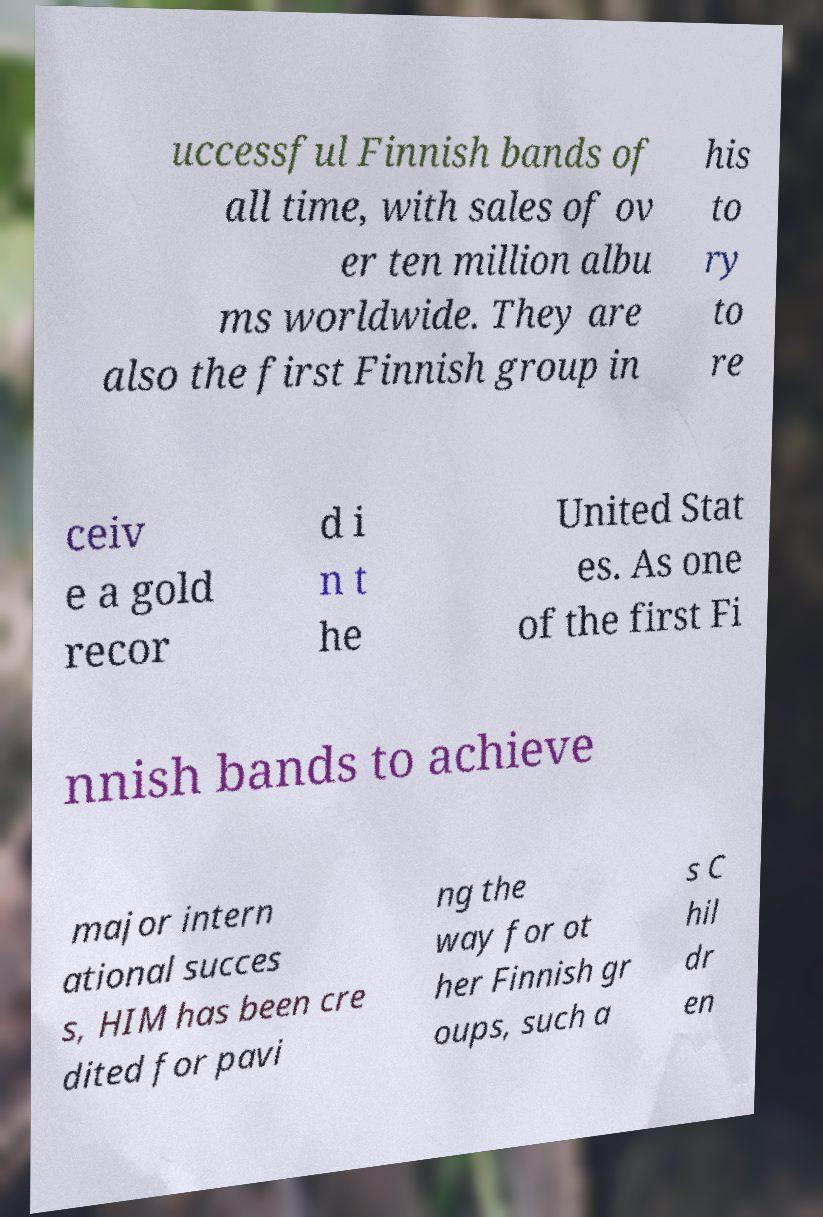There's text embedded in this image that I need extracted. Can you transcribe it verbatim? uccessful Finnish bands of all time, with sales of ov er ten million albu ms worldwide. They are also the first Finnish group in his to ry to re ceiv e a gold recor d i n t he United Stat es. As one of the first Fi nnish bands to achieve major intern ational succes s, HIM has been cre dited for pavi ng the way for ot her Finnish gr oups, such a s C hil dr en 